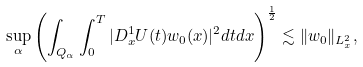<formula> <loc_0><loc_0><loc_500><loc_500>\sup _ { \alpha } \left ( \int _ { Q _ { \alpha } } \int _ { 0 } ^ { T } | D _ { x } ^ { 1 } U ( t ) w _ { 0 } ( x ) | ^ { 2 } d t d x \right ) ^ { \frac { 1 } { 2 } } \lesssim \| w _ { 0 } \| _ { L _ { x } ^ { 2 } } ,</formula> 